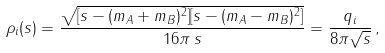<formula> <loc_0><loc_0><loc_500><loc_500>\rho _ { i } ( s ) = \frac { \sqrt { [ s - ( m _ { A } + m _ { B } ) ^ { 2 } ] [ s - ( m _ { A } - m _ { B } ) ^ { 2 } ] } } { 1 6 \pi \, s } = \frac { q _ { i } } { 8 \pi \sqrt { s } } \, ,</formula> 